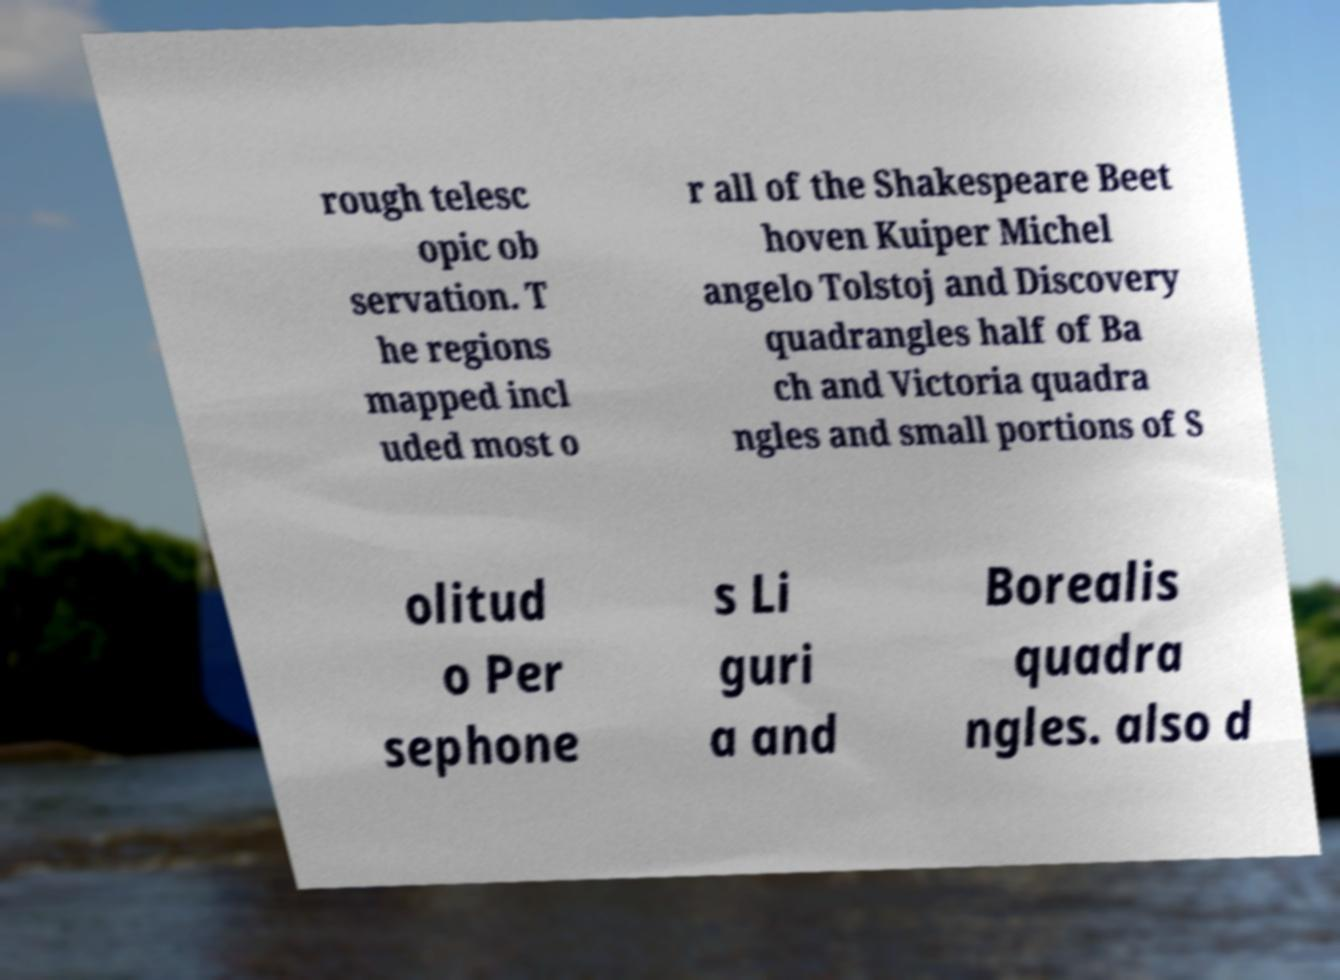Can you read and provide the text displayed in the image?This photo seems to have some interesting text. Can you extract and type it out for me? rough telesc opic ob servation. T he regions mapped incl uded most o r all of the Shakespeare Beet hoven Kuiper Michel angelo Tolstoj and Discovery quadrangles half of Ba ch and Victoria quadra ngles and small portions of S olitud o Per sephone s Li guri a and Borealis quadra ngles. also d 